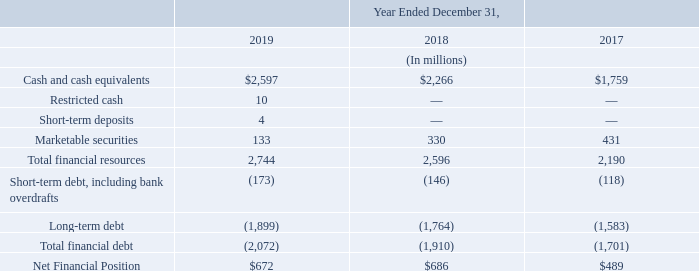Our Net Financial Position as of December 31, 2019 was a net cash position of $672 million, decreasing compared to the net cash position of $686 million at December 31, 2018.
At December 31, 2019, our financial debt was $2,072 million, composed of (i) $173 million of current portion of long-term debt and (ii) $1,899 million of long-term debt. The breakdown of our total financial debt included: (i) $1,354 million in the senior unsecured convertible bonds issued in 2017, (ii) $706 million in European Investment Bank loans (the “EIB Loans”), and (iii) $12 million in loans from other funding programs and other long-term loans.
The EIB Loans are comprised of three long-term amortizing credit facilities as part of our R&D funding programs. The first, signed in 2010, is a €350 million multi-currency loan to support our industrial and R&D programs. It was drawn mainly in U.S. dollars for an amount of $321 million and only partially in Euros for an amount of €100 million, of which $55 million remained outstanding as of December 31, 2019.
The second, signed in 2013, is a €350 million multi-currency loan which also supports our R&D programs. It was drawn in U.S. dollars for an amount of $471 million, of which $118 million is outstanding as of December 31, 2019. The third, signed in August 2017 for a total aggregate amount of €500 million in relation to R&D and capital expenditure investments in the European Union. It was fully drawn in Euros corresponding to $533 million outstanding as of December 31, 2019.
What was the company's net cash position as of December 31, 2019? $672 million. What was the financial debt comprised of as at December 31, 2019? (i) $173 million of current portion of long-term debt and (ii) $1,899 million of long-term debt. What was the first EIB loan amount that was signed? €350 million. What was the increase / (decrease) in cash and cash equivalents from 2018 to 2019?
Answer scale should be: million. 2,597 - 2,266
Answer: 331. What is the average restricted cash?
Answer scale should be: million. (10 + 0 + 0) / 3
Answer: 3.33. What is the percentage increase / (decrease) in the Total financial resources from 2018 to 2019?
Answer scale should be: percent. 2,744 / 2,596 - 1
Answer: 5.7. 